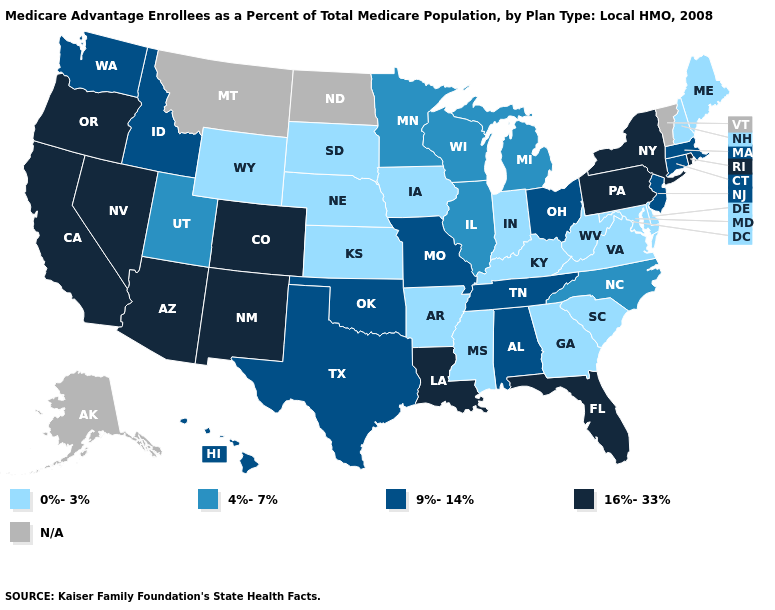What is the value of Oklahoma?
Be succinct. 9%-14%. Does the map have missing data?
Keep it brief. Yes. Name the states that have a value in the range 0%-3%?
Be succinct. Arkansas, Delaware, Georgia, Iowa, Indiana, Kansas, Kentucky, Maryland, Maine, Mississippi, Nebraska, New Hampshire, South Carolina, South Dakota, Virginia, West Virginia, Wyoming. What is the value of Michigan?
Write a very short answer. 4%-7%. Does Kansas have the lowest value in the MidWest?
Concise answer only. Yes. Which states hav the highest value in the Northeast?
Write a very short answer. New York, Pennsylvania, Rhode Island. What is the value of Alabama?
Keep it brief. 9%-14%. Name the states that have a value in the range N/A?
Keep it brief. Alaska, Montana, North Dakota, Vermont. Among the states that border Minnesota , does Wisconsin have the lowest value?
Short answer required. No. Among the states that border Louisiana , does Arkansas have the lowest value?
Give a very brief answer. Yes. Among the states that border Virginia , which have the lowest value?
Quick response, please. Kentucky, Maryland, West Virginia. Does Wyoming have the lowest value in the West?
Concise answer only. Yes. Among the states that border Arkansas , does Mississippi have the lowest value?
Give a very brief answer. Yes. 